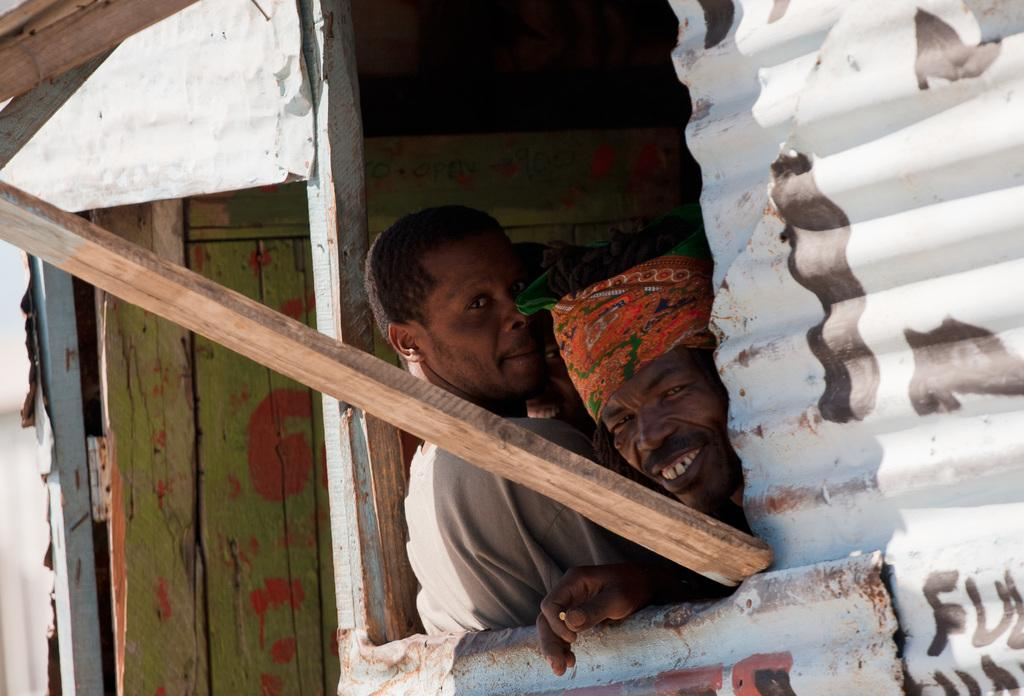What type of wall is on the right side of the image? There is an asbestos wall on the right side of the image. What can be seen near the asbestos wall? There are people near the asbestos wall. What object made of wood is visible in the image? There is a wooden stick in the image. What type of structure can be seen in the background of the image? There is a wooden door in the background of the image. How many minutes does it take for the tree to grow in the image? There is no tree present in the image, so it is not possible to determine how long it would take for a tree to grow. 